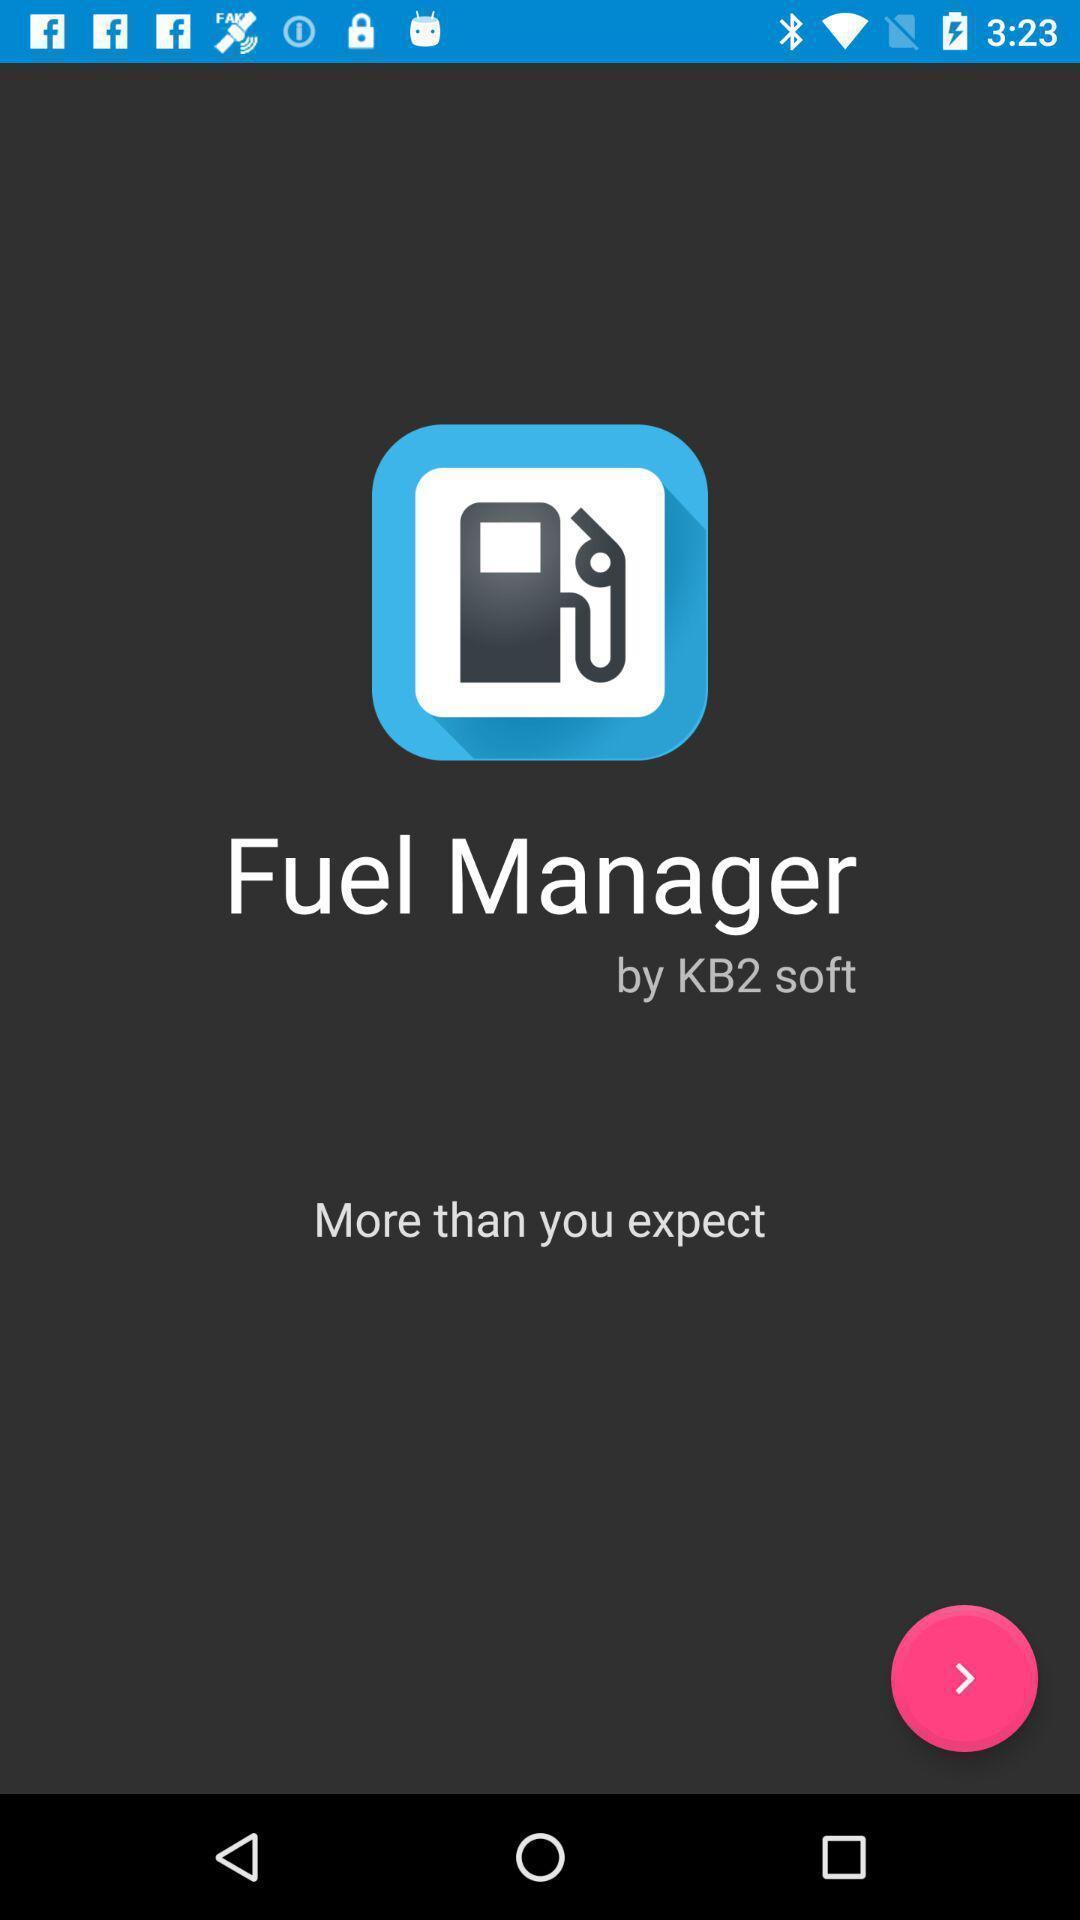Describe the key features of this screenshot. Welcome page for a fuel managing app. 